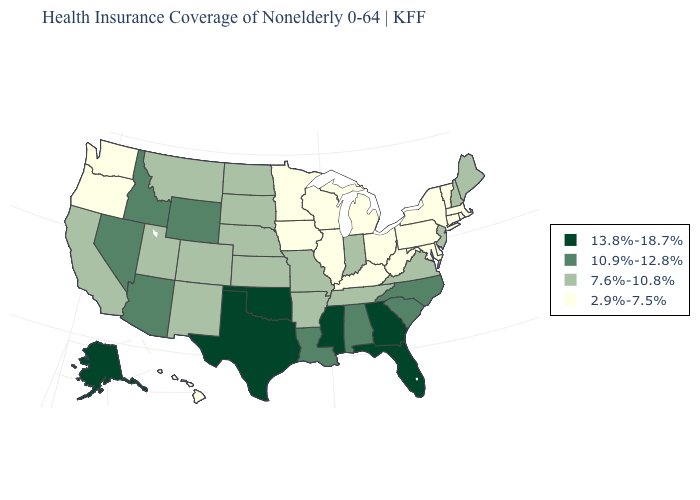Name the states that have a value in the range 7.6%-10.8%?
Keep it brief. Arkansas, California, Colorado, Indiana, Kansas, Maine, Missouri, Montana, Nebraska, New Hampshire, New Jersey, New Mexico, North Dakota, South Dakota, Tennessee, Utah, Virginia. Name the states that have a value in the range 2.9%-7.5%?
Short answer required. Connecticut, Delaware, Hawaii, Illinois, Iowa, Kentucky, Maryland, Massachusetts, Michigan, Minnesota, New York, Ohio, Oregon, Pennsylvania, Rhode Island, Vermont, Washington, West Virginia, Wisconsin. What is the value of Michigan?
Quick response, please. 2.9%-7.5%. Does New Jersey have the highest value in the Northeast?
Give a very brief answer. Yes. Among the states that border Iowa , does Minnesota have the lowest value?
Concise answer only. Yes. What is the lowest value in the USA?
Give a very brief answer. 2.9%-7.5%. Name the states that have a value in the range 2.9%-7.5%?
Quick response, please. Connecticut, Delaware, Hawaii, Illinois, Iowa, Kentucky, Maryland, Massachusetts, Michigan, Minnesota, New York, Ohio, Oregon, Pennsylvania, Rhode Island, Vermont, Washington, West Virginia, Wisconsin. Does Kentucky have the lowest value in the South?
Concise answer only. Yes. Does Rhode Island have the highest value in the Northeast?
Quick response, please. No. What is the value of Georgia?
Answer briefly. 13.8%-18.7%. What is the value of Utah?
Answer briefly. 7.6%-10.8%. Which states have the lowest value in the Northeast?
Concise answer only. Connecticut, Massachusetts, New York, Pennsylvania, Rhode Island, Vermont. Name the states that have a value in the range 2.9%-7.5%?
Concise answer only. Connecticut, Delaware, Hawaii, Illinois, Iowa, Kentucky, Maryland, Massachusetts, Michigan, Minnesota, New York, Ohio, Oregon, Pennsylvania, Rhode Island, Vermont, Washington, West Virginia, Wisconsin. Does Idaho have the lowest value in the West?
Give a very brief answer. No. Name the states that have a value in the range 13.8%-18.7%?
Give a very brief answer. Alaska, Florida, Georgia, Mississippi, Oklahoma, Texas. 